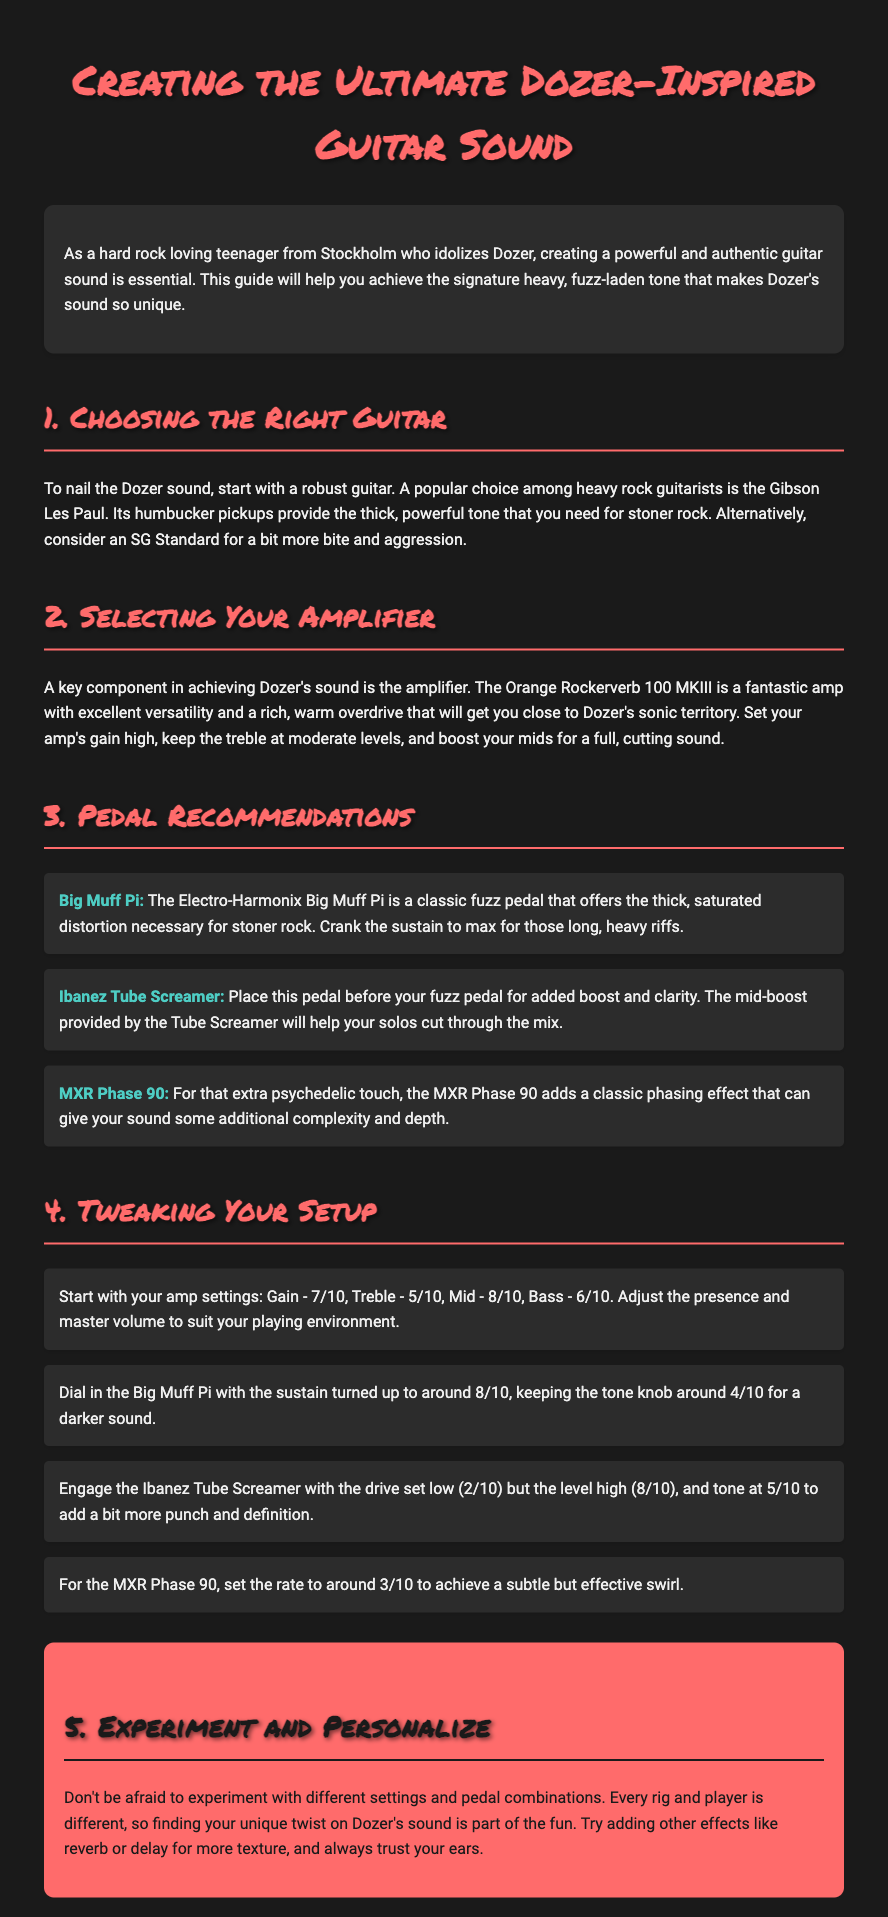What is the title of the guide? The title of the guide is found at the heading, which is "Creating the Ultimate Dozer-Inspired Guitar Sound".
Answer: Creating the Ultimate Dozer-Inspired Guitar Sound Which guitar model is recommended for a powerful tone? The document recommends the Gibson Les Paul for achieving a thick, powerful tone.
Answer: Gibson Les Paul What is the recommended gain setting for the amplifier? The recommended gain setting is mentioned in the section on tweaking setups, specifically set to 7/10.
Answer: 7/10 What pedal should be placed before the fuzz pedal? The Ibanez Tube Screamer is suggested to be placed before the fuzz pedal for added boost.
Answer: Ibanez Tube Screamer What is the sustain setting for the Big Muff Pi? The document specifies that the sustain should be cranked to max, which is around 8/10.
Answer: 8/10 How many pedals are recommended in the guide? There are three pedals recommended in the Pedal Recommendations section.
Answer: Three What is the goal of the "Experiment and Personalize" section? The goal is to encourage users to try different settings and pedal combinations for a unique sound.
Answer: Try different settings What is the model of the amplifier suggested in the guide? The recommended amplifier model is mentioned as the Orange Rockerverb 100 MKIII.
Answer: Orange Rockerverb 100 MKIII What is the tone setting for the Big Muff Pi? The document advises keeping the tone knob around 4/10 for a darker sound.
Answer: 4/10 